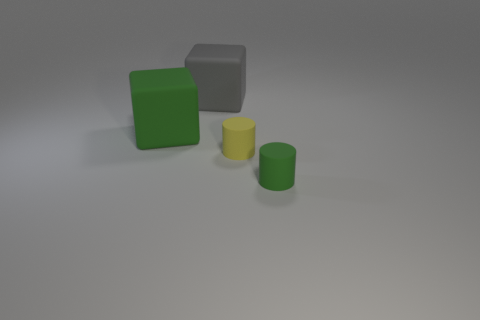Add 4 gray shiny objects. How many objects exist? 8 Add 3 small green metallic cylinders. How many small green metallic cylinders exist? 3 Subtract 1 yellow cylinders. How many objects are left? 3 Subtract all tiny rubber things. Subtract all small yellow things. How many objects are left? 1 Add 4 cylinders. How many cylinders are left? 6 